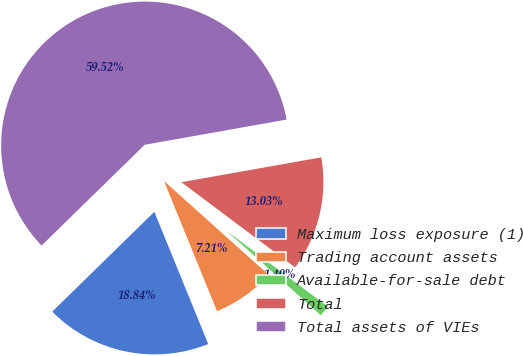<chart> <loc_0><loc_0><loc_500><loc_500><pie_chart><fcel>Maximum loss exposure (1)<fcel>Trading account assets<fcel>Available-for-sale debt<fcel>Total<fcel>Total assets of VIEs<nl><fcel>18.84%<fcel>7.21%<fcel>1.4%<fcel>13.03%<fcel>59.52%<nl></chart> 